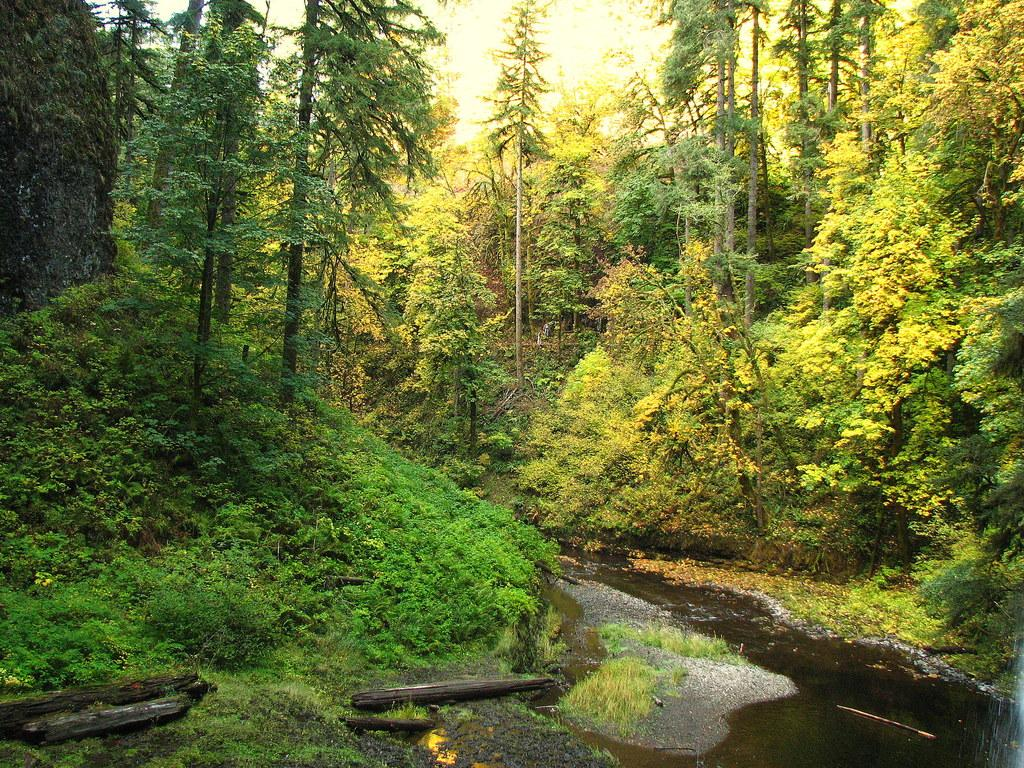What is located in the foreground of the picture? There are wooden logs, plants, water, and grass in the foreground of the picture. What types of vegetation can be seen in the foreground? Plants and grass are visible in the foreground of the picture. What is the primary element in the foreground? Water is the primary element in the foreground of the picture. What can be seen in the center and background of the picture? There are trees and plants in the center and background of the picture. Can you see a boundary between the grass and the water in the image? There is no mention of a boundary between the grass and the water in the image. How many basketballs are visible in the image? There are no basketballs present in the image. 